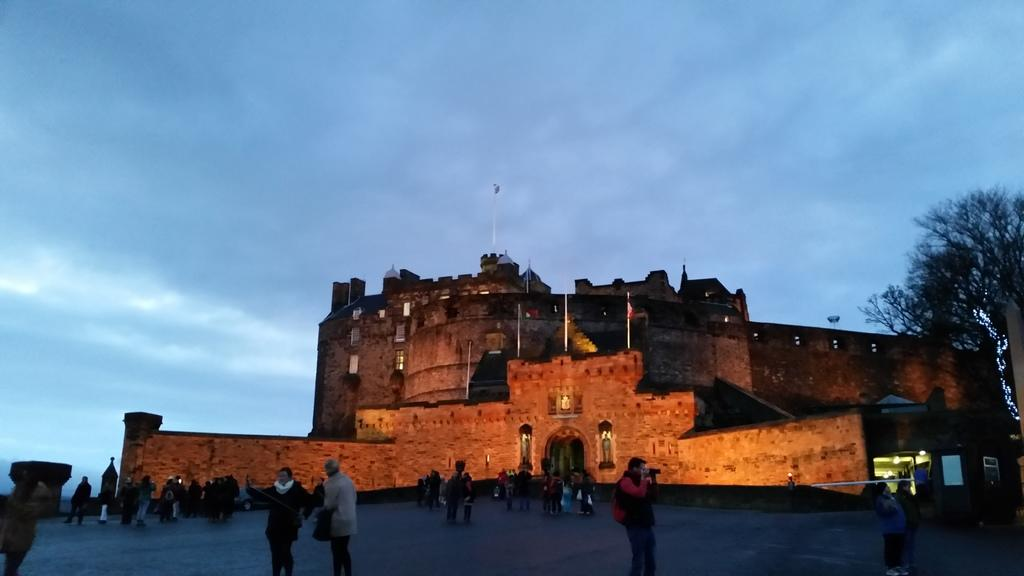What type of structure is present in the image? There is a building in the image. What architectural feature can be seen in the middle of the image? There is an arch in the middle of the image. Who or what is present in the image? There are people in the image. What can be used for illumination in the image? There are lights in the image. What type of vegetation is visible in the image? There are trees in the image. What part of the natural environment is visible in the image? The sky is visible in the image. What type of furniture is being used by the people in the image? There is no furniture visible in the image; only a building, an arch, people, lights, trees, and the sky are present. What topic are the people in the image talking about? The image does not provide any information about the conversation or topic of discussion among the people. 